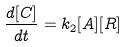<formula> <loc_0><loc_0><loc_500><loc_500>\frac { d [ C ] } { d t } = k _ { 2 } [ A ] [ R ]</formula> 